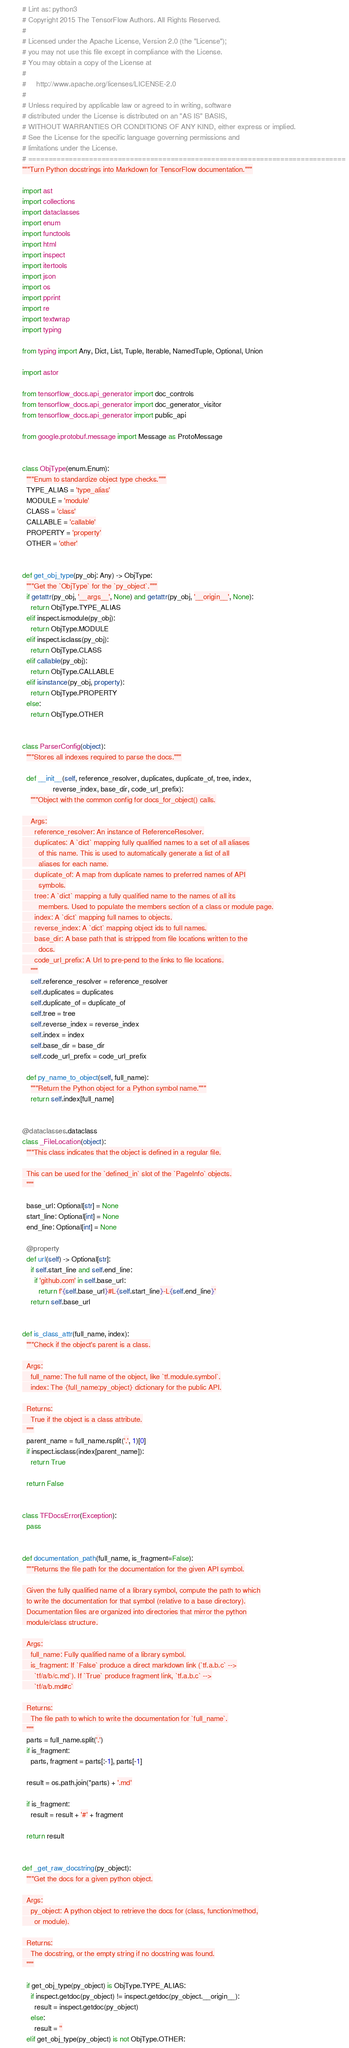<code> <loc_0><loc_0><loc_500><loc_500><_Python_># Lint as: python3
# Copyright 2015 The TensorFlow Authors. All Rights Reserved.
#
# Licensed under the Apache License, Version 2.0 (the "License");
# you may not use this file except in compliance with the License.
# You may obtain a copy of the License at
#
#     http://www.apache.org/licenses/LICENSE-2.0
#
# Unless required by applicable law or agreed to in writing, software
# distributed under the License is distributed on an "AS IS" BASIS,
# WITHOUT WARRANTIES OR CONDITIONS OF ANY KIND, either express or implied.
# See the License for the specific language governing permissions and
# limitations under the License.
# ==============================================================================
"""Turn Python docstrings into Markdown for TensorFlow documentation."""

import ast
import collections
import dataclasses
import enum
import functools
import html
import inspect
import itertools
import json
import os
import pprint
import re
import textwrap
import typing

from typing import Any, Dict, List, Tuple, Iterable, NamedTuple, Optional, Union

import astor

from tensorflow_docs.api_generator import doc_controls
from tensorflow_docs.api_generator import doc_generator_visitor
from tensorflow_docs.api_generator import public_api

from google.protobuf.message import Message as ProtoMessage


class ObjType(enum.Enum):
  """Enum to standardize object type checks."""
  TYPE_ALIAS = 'type_alias'
  MODULE = 'module'
  CLASS = 'class'
  CALLABLE = 'callable'
  PROPERTY = 'property'
  OTHER = 'other'


def get_obj_type(py_obj: Any) -> ObjType:
  """Get the `ObjType` for the `py_object`."""
  if getattr(py_obj, '__args__', None) and getattr(py_obj, '__origin__', None):
    return ObjType.TYPE_ALIAS
  elif inspect.ismodule(py_obj):
    return ObjType.MODULE
  elif inspect.isclass(py_obj):
    return ObjType.CLASS
  elif callable(py_obj):
    return ObjType.CALLABLE
  elif isinstance(py_obj, property):
    return ObjType.PROPERTY
  else:
    return ObjType.OTHER


class ParserConfig(object):
  """Stores all indexes required to parse the docs."""

  def __init__(self, reference_resolver, duplicates, duplicate_of, tree, index,
               reverse_index, base_dir, code_url_prefix):
    """Object with the common config for docs_for_object() calls.

    Args:
      reference_resolver: An instance of ReferenceResolver.
      duplicates: A `dict` mapping fully qualified names to a set of all aliases
        of this name. This is used to automatically generate a list of all
        aliases for each name.
      duplicate_of: A map from duplicate names to preferred names of API
        symbols.
      tree: A `dict` mapping a fully qualified name to the names of all its
        members. Used to populate the members section of a class or module page.
      index: A `dict` mapping full names to objects.
      reverse_index: A `dict` mapping object ids to full names.
      base_dir: A base path that is stripped from file locations written to the
        docs.
      code_url_prefix: A Url to pre-pend to the links to file locations.
    """
    self.reference_resolver = reference_resolver
    self.duplicates = duplicates
    self.duplicate_of = duplicate_of
    self.tree = tree
    self.reverse_index = reverse_index
    self.index = index
    self.base_dir = base_dir
    self.code_url_prefix = code_url_prefix

  def py_name_to_object(self, full_name):
    """Return the Python object for a Python symbol name."""
    return self.index[full_name]


@dataclasses.dataclass
class _FileLocation(object):
  """This class indicates that the object is defined in a regular file.

  This can be used for the `defined_in` slot of the `PageInfo` objects.
  """

  base_url: Optional[str] = None
  start_line: Optional[int] = None
  end_line: Optional[int] = None

  @property
  def url(self) -> Optional[str]:
    if self.start_line and self.end_line:
      if 'github.com' in self.base_url:
        return f'{self.base_url}#L{self.start_line}-L{self.end_line}'
    return self.base_url


def is_class_attr(full_name, index):
  """Check if the object's parent is a class.

  Args:
    full_name: The full name of the object, like `tf.module.symbol`.
    index: The {full_name:py_object} dictionary for the public API.

  Returns:
    True if the object is a class attribute.
  """
  parent_name = full_name.rsplit('.', 1)[0]
  if inspect.isclass(index[parent_name]):
    return True

  return False


class TFDocsError(Exception):
  pass


def documentation_path(full_name, is_fragment=False):
  """Returns the file path for the documentation for the given API symbol.

  Given the fully qualified name of a library symbol, compute the path to which
  to write the documentation for that symbol (relative to a base directory).
  Documentation files are organized into directories that mirror the python
  module/class structure.

  Args:
    full_name: Fully qualified name of a library symbol.
    is_fragment: If `False` produce a direct markdown link (`tf.a.b.c` -->
      `tf/a/b/c.md`). If `True` produce fragment link, `tf.a.b.c` -->
      `tf/a/b.md#c`

  Returns:
    The file path to which to write the documentation for `full_name`.
  """
  parts = full_name.split('.')
  if is_fragment:
    parts, fragment = parts[:-1], parts[-1]

  result = os.path.join(*parts) + '.md'

  if is_fragment:
    result = result + '#' + fragment

  return result


def _get_raw_docstring(py_object):
  """Get the docs for a given python object.

  Args:
    py_object: A python object to retrieve the docs for (class, function/method,
      or module).

  Returns:
    The docstring, or the empty string if no docstring was found.
  """

  if get_obj_type(py_object) is ObjType.TYPE_ALIAS:
    if inspect.getdoc(py_object) != inspect.getdoc(py_object.__origin__):
      result = inspect.getdoc(py_object)
    else:
      result = ''
  elif get_obj_type(py_object) is not ObjType.OTHER:</code> 